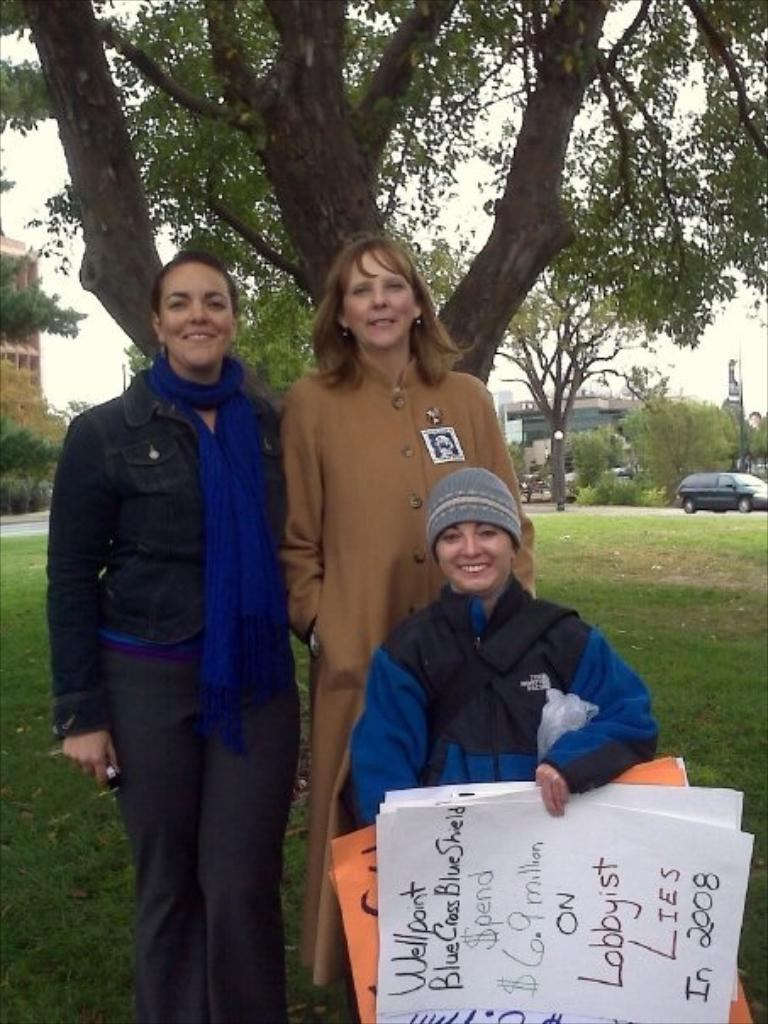How many people are present in the image? There are three ladies in the image. What is one of the ladies holding in her hand? One of the ladies is holding papers in her hand. What can be seen in the background of the image? There are trees and a car in the background of the image. What type of vegetable is being painted by the lizards in the image? There are no lizards or paint present in the image, so it is not possible to answer that question. 